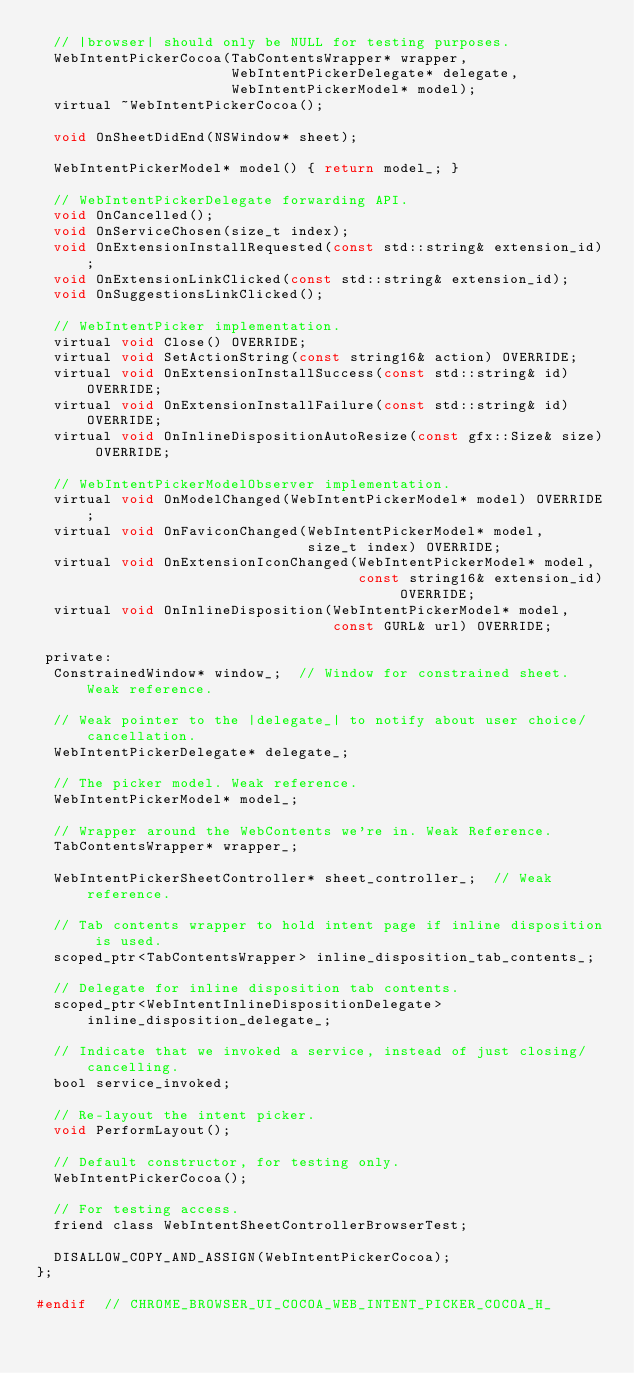<code> <loc_0><loc_0><loc_500><loc_500><_C_>  // |browser| should only be NULL for testing purposes.
  WebIntentPickerCocoa(TabContentsWrapper* wrapper,
                       WebIntentPickerDelegate* delegate,
                       WebIntentPickerModel* model);
  virtual ~WebIntentPickerCocoa();

  void OnSheetDidEnd(NSWindow* sheet);

  WebIntentPickerModel* model() { return model_; }

  // WebIntentPickerDelegate forwarding API.
  void OnCancelled();
  void OnServiceChosen(size_t index);
  void OnExtensionInstallRequested(const std::string& extension_id);
  void OnExtensionLinkClicked(const std::string& extension_id);
  void OnSuggestionsLinkClicked();

  // WebIntentPicker implementation.
  virtual void Close() OVERRIDE;
  virtual void SetActionString(const string16& action) OVERRIDE;
  virtual void OnExtensionInstallSuccess(const std::string& id) OVERRIDE;
  virtual void OnExtensionInstallFailure(const std::string& id) OVERRIDE;
  virtual void OnInlineDispositionAutoResize(const gfx::Size& size) OVERRIDE;

  // WebIntentPickerModelObserver implementation.
  virtual void OnModelChanged(WebIntentPickerModel* model) OVERRIDE;
  virtual void OnFaviconChanged(WebIntentPickerModel* model,
                                size_t index) OVERRIDE;
  virtual void OnExtensionIconChanged(WebIntentPickerModel* model,
                                      const string16& extension_id) OVERRIDE;
  virtual void OnInlineDisposition(WebIntentPickerModel* model,
                                   const GURL& url) OVERRIDE;

 private:
  ConstrainedWindow* window_;  // Window for constrained sheet. Weak reference.

  // Weak pointer to the |delegate_| to notify about user choice/cancellation.
  WebIntentPickerDelegate* delegate_;

  // The picker model. Weak reference.
  WebIntentPickerModel* model_;

  // Wrapper around the WebContents we're in. Weak Reference.
  TabContentsWrapper* wrapper_;

  WebIntentPickerSheetController* sheet_controller_;  // Weak reference.

  // Tab contents wrapper to hold intent page if inline disposition is used.
  scoped_ptr<TabContentsWrapper> inline_disposition_tab_contents_;

  // Delegate for inline disposition tab contents.
  scoped_ptr<WebIntentInlineDispositionDelegate> inline_disposition_delegate_;

  // Indicate that we invoked a service, instead of just closing/cancelling.
  bool service_invoked;

  // Re-layout the intent picker.
  void PerformLayout();

  // Default constructor, for testing only.
  WebIntentPickerCocoa();

  // For testing access.
  friend class WebIntentSheetControllerBrowserTest;

  DISALLOW_COPY_AND_ASSIGN(WebIntentPickerCocoa);
};

#endif  // CHROME_BROWSER_UI_COCOA_WEB_INTENT_PICKER_COCOA_H_
</code> 